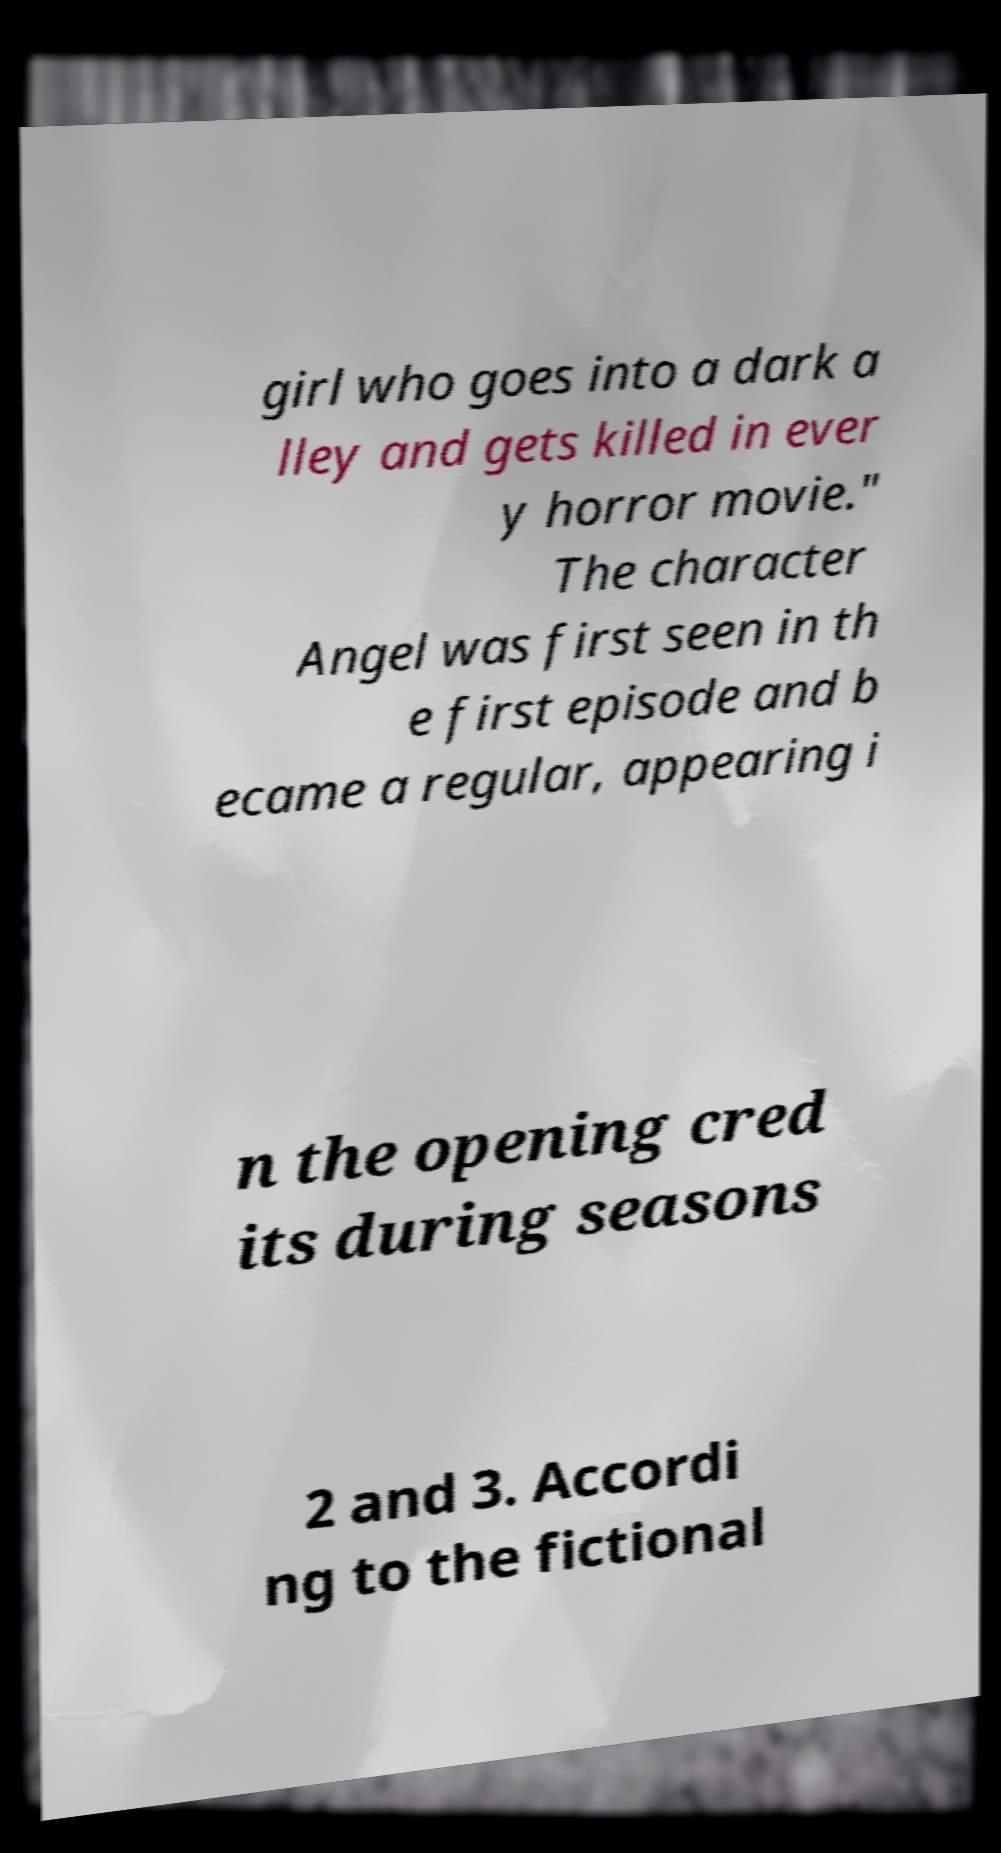Can you accurately transcribe the text from the provided image for me? girl who goes into a dark a lley and gets killed in ever y horror movie." The character Angel was first seen in th e first episode and b ecame a regular, appearing i n the opening cred its during seasons 2 and 3. Accordi ng to the fictional 